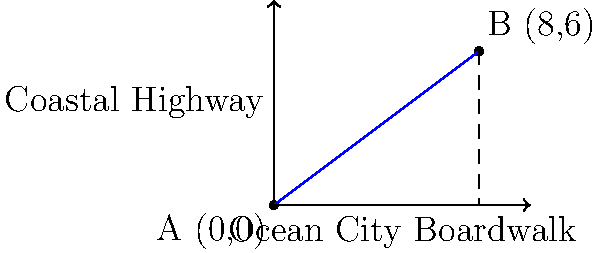As the owner of a sports bar in Ocean City, you're planning a promotional event that involves a scavenger hunt. Two key locations for the hunt are your bar (point A) and a popular beach spot (point B). Given that each unit on the map represents 0.5 miles, and the coordinates of the two points are A(0,0) and B(8,6), what is the shortest distance between these two locations? To find the shortest distance between two points on a map, we can use the distance formula derived from the Pythagorean theorem:

1) The distance formula is: $d = \sqrt{(x_2-x_1)^2 + (y_2-y_1)^2}$

2) We have:
   Point A: $(x_1, y_1) = (0, 0)$
   Point B: $(x_2, y_2) = (8, 6)$

3) Let's substitute these values into the formula:
   $d = \sqrt{(8-0)^2 + (6-0)^2}$

4) Simplify:
   $d = \sqrt{8^2 + 6^2}$
   $d = \sqrt{64 + 36}$
   $d = \sqrt{100}$
   $d = 10$

5) Remember that each unit represents 0.5 miles, so we need to multiply our result by 0.5:
   $10 \times 0.5 = 5$ miles

Therefore, the shortest distance between your bar and the beach spot is 5 miles.
Answer: 5 miles 